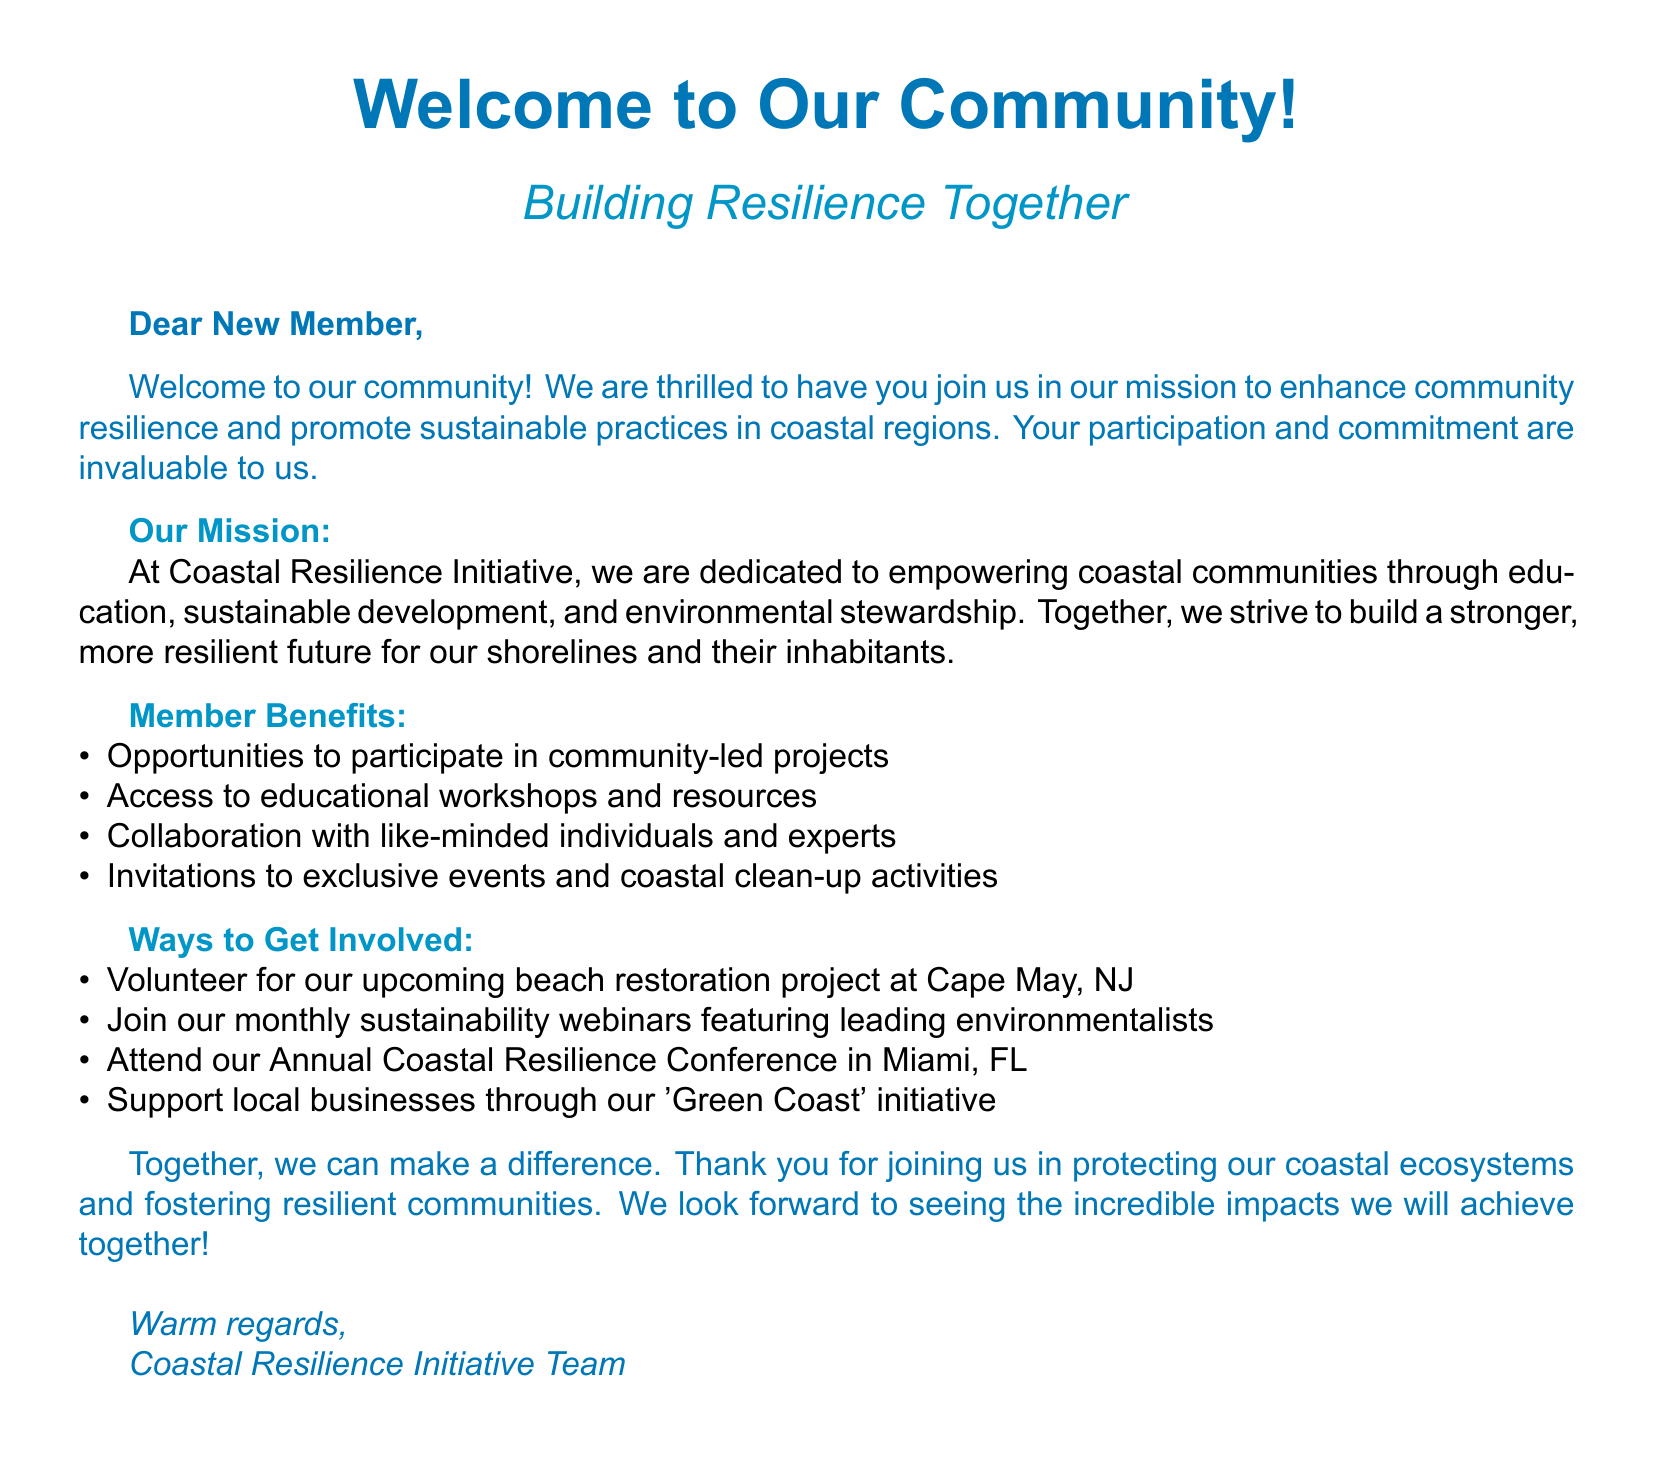What is the mission of the organization? The mission is to empower coastal communities through education, sustainable development, and environmental stewardship.
Answer: Empowering coastal communities What are two benefits of membership? Membership benefits listed include opportunities to participate in projects and access to workshops and resources.
Answer: Participate in community-led projects, access to educational workshops Where is the beach restoration project located? The location of the beach restoration project mentioned is Cape May, NJ.
Answer: Cape May, NJ What color is used for the accent in the card design? The accent color used in the design is defined in the document as a specific hex value.
Answer: #00B4D8 How many member benefits are listed in the card? The list of member benefits includes four distinct items provided in the document.
Answer: Four Who is the card addressed to? The greeting card is specifically welcoming new members, indicating the audience it is addressing.
Answer: New Member What is one way to get involved mentioned in the card? One way to get involved is to join the monthly sustainability webinars featuring leading environmentalists.
Answer: Join monthly sustainability webinars What type of document is this? The document serves as a welcome message for new members of an organization, fitting within greeting card formats.
Answer: Introduction Card 